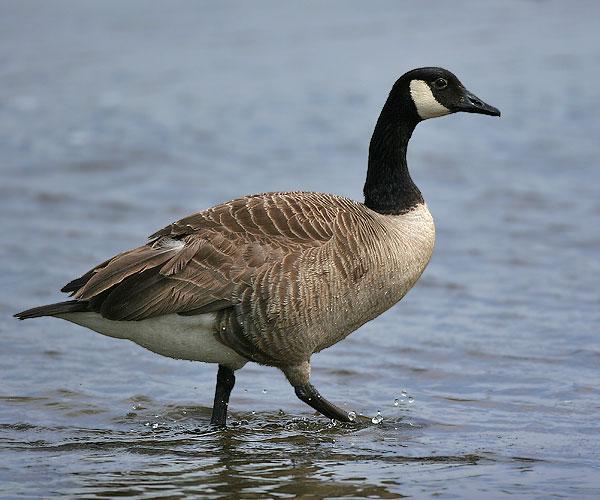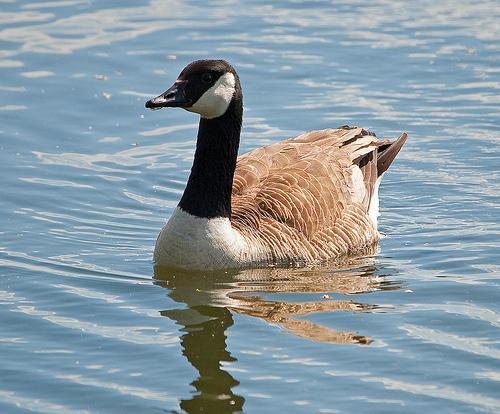The first image is the image on the left, the second image is the image on the right. Considering the images on both sides, is "The left image shows fowl standing on grass." valid? Answer yes or no. No. 